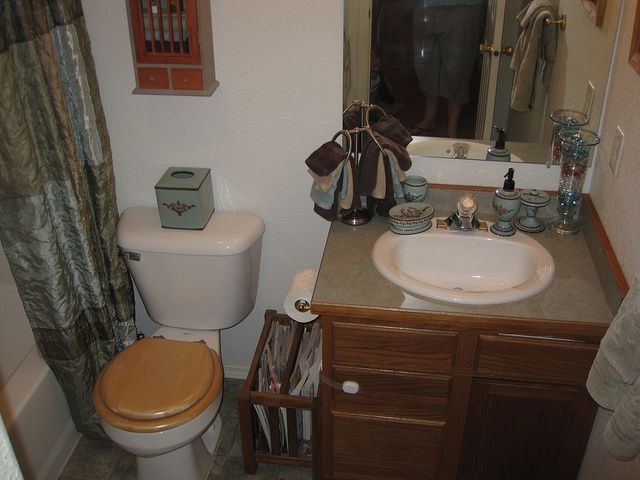Describe the objects in this image and their specific colors. I can see toilet in black, gray, maroon, and darkgray tones, sink in black, darkgray, and gray tones, people in black and purple tones, vase in black and gray tones, and bowl in black, gray, and maroon tones in this image. 